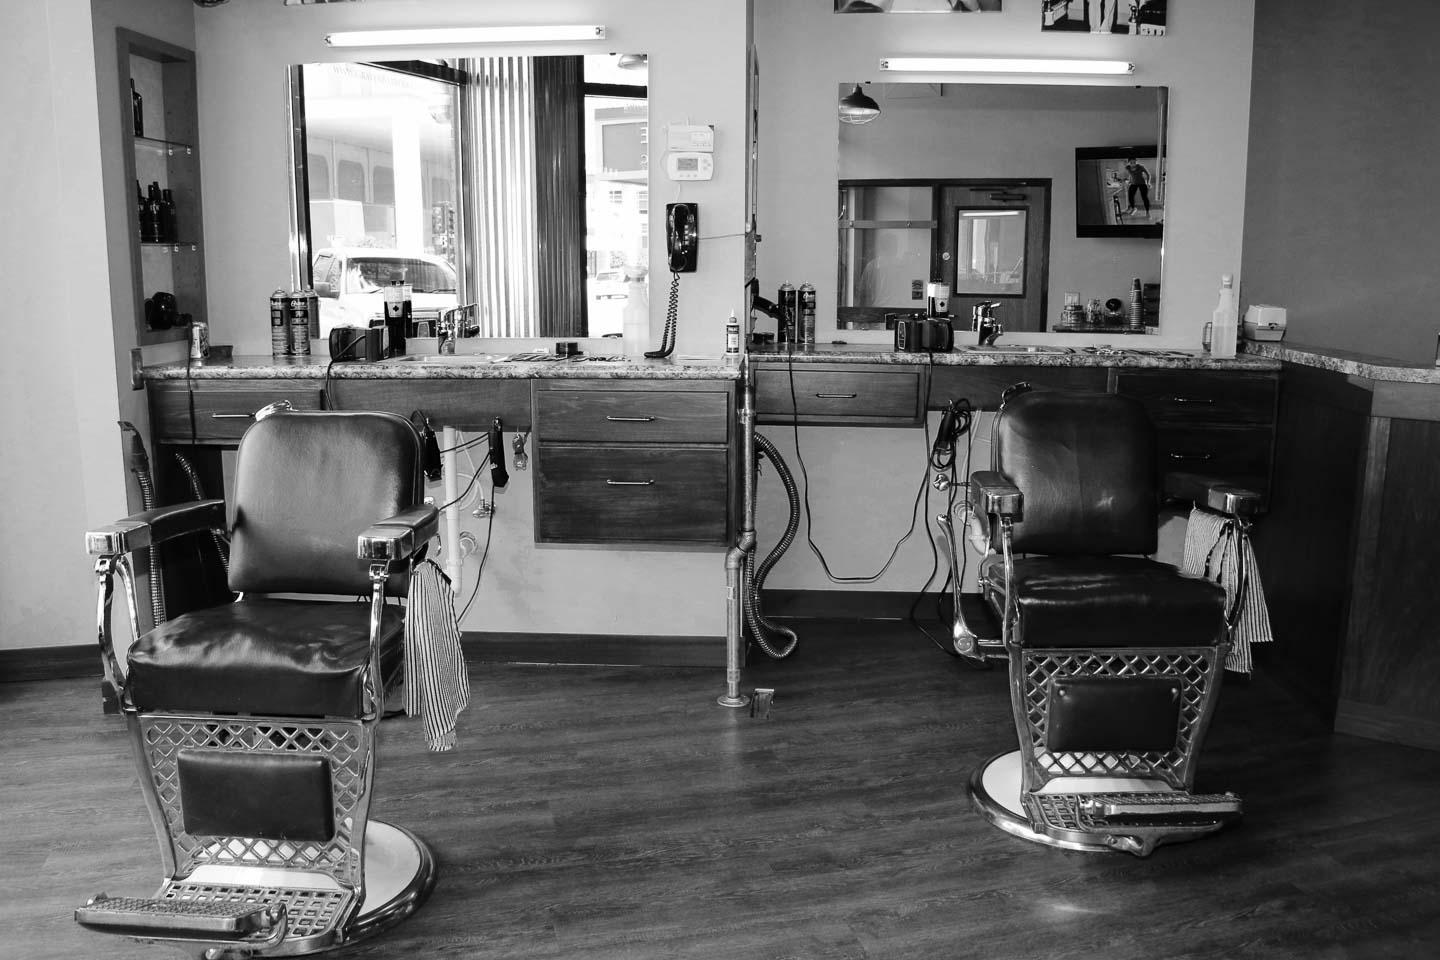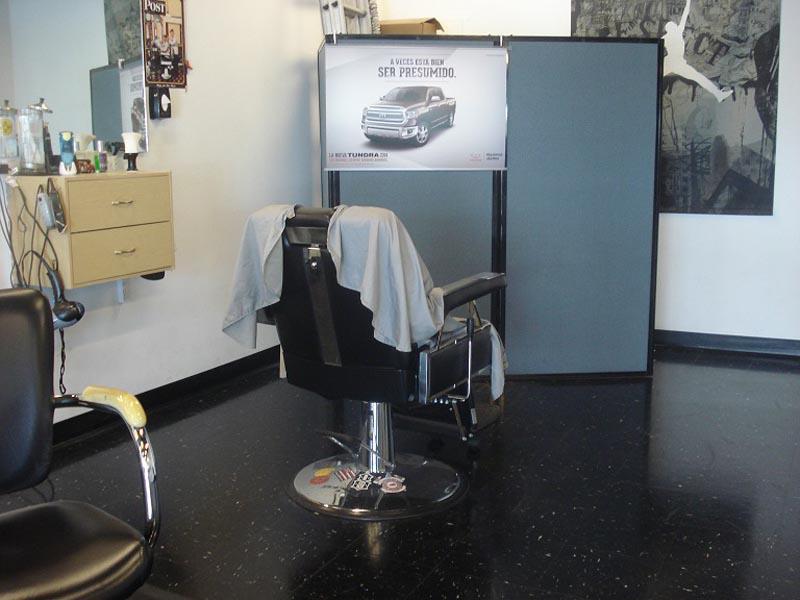The first image is the image on the left, the second image is the image on the right. Examine the images to the left and right. Is the description "There is a total of four barber chairs." accurate? Answer yes or no. Yes. The first image is the image on the left, the second image is the image on the right. Considering the images on both sides, is "Two black, forward facing, barber chairs are in one of the images." valid? Answer yes or no. Yes. 